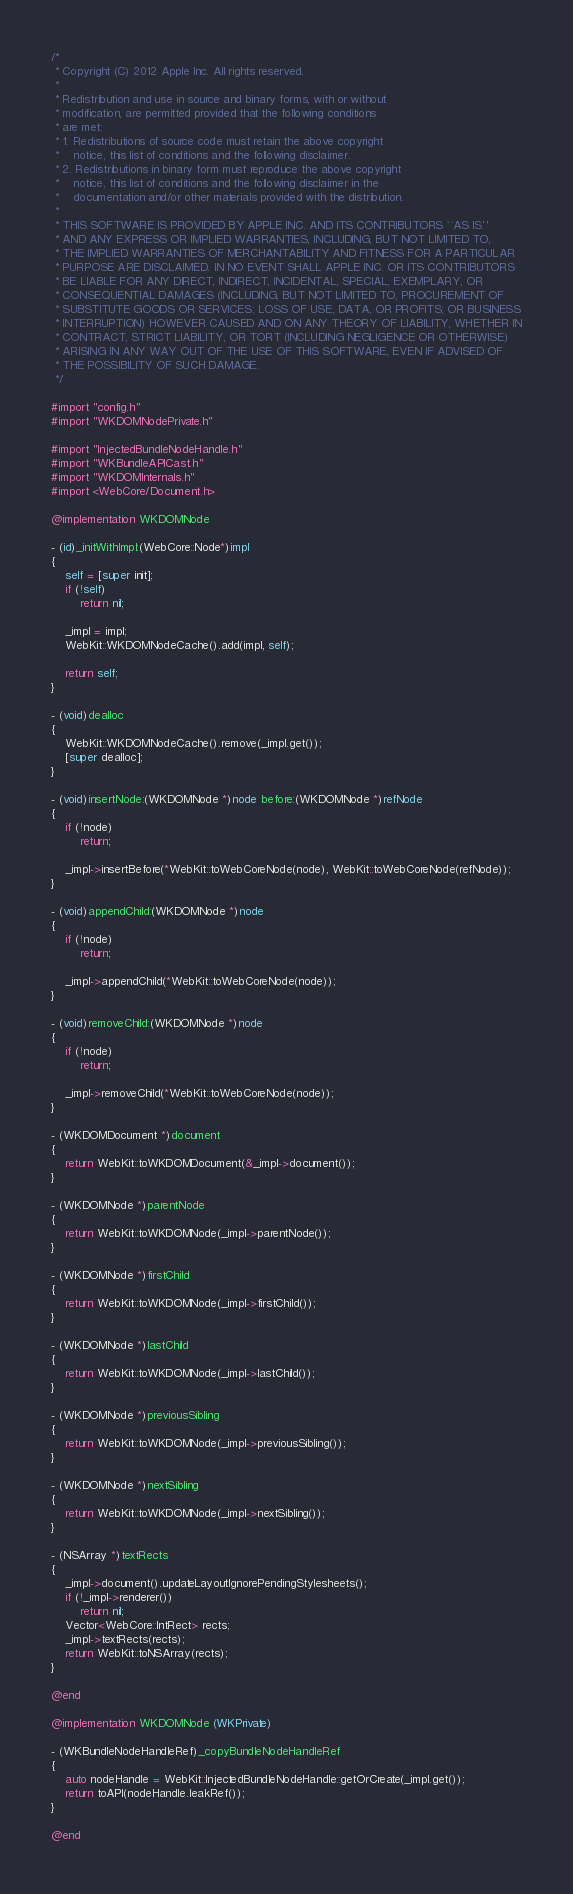<code> <loc_0><loc_0><loc_500><loc_500><_ObjectiveC_>/*
 * Copyright (C) 2012 Apple Inc. All rights reserved.
 *
 * Redistribution and use in source and binary forms, with or without
 * modification, are permitted provided that the following conditions
 * are met:
 * 1. Redistributions of source code must retain the above copyright
 *    notice, this list of conditions and the following disclaimer.
 * 2. Redistributions in binary form must reproduce the above copyright
 *    notice, this list of conditions and the following disclaimer in the
 *    documentation and/or other materials provided with the distribution.
 *
 * THIS SOFTWARE IS PROVIDED BY APPLE INC. AND ITS CONTRIBUTORS ``AS IS''
 * AND ANY EXPRESS OR IMPLIED WARRANTIES, INCLUDING, BUT NOT LIMITED TO,
 * THE IMPLIED WARRANTIES OF MERCHANTABILITY AND FITNESS FOR A PARTICULAR
 * PURPOSE ARE DISCLAIMED. IN NO EVENT SHALL APPLE INC. OR ITS CONTRIBUTORS
 * BE LIABLE FOR ANY DIRECT, INDIRECT, INCIDENTAL, SPECIAL, EXEMPLARY, OR
 * CONSEQUENTIAL DAMAGES (INCLUDING, BUT NOT LIMITED TO, PROCUREMENT OF
 * SUBSTITUTE GOODS OR SERVICES; LOSS OF USE, DATA, OR PROFITS; OR BUSINESS
 * INTERRUPTION) HOWEVER CAUSED AND ON ANY THEORY OF LIABILITY, WHETHER IN
 * CONTRACT, STRICT LIABILITY, OR TORT (INCLUDING NEGLIGENCE OR OTHERWISE)
 * ARISING IN ANY WAY OUT OF THE USE OF THIS SOFTWARE, EVEN IF ADVISED OF
 * THE POSSIBILITY OF SUCH DAMAGE.
 */

#import "config.h"
#import "WKDOMNodePrivate.h"

#import "InjectedBundleNodeHandle.h"
#import "WKBundleAPICast.h"
#import "WKDOMInternals.h"
#import <WebCore/Document.h>

@implementation WKDOMNode

- (id)_initWithImpl:(WebCore::Node*)impl
{
    self = [super init];
    if (!self)
        return nil;

    _impl = impl;
    WebKit::WKDOMNodeCache().add(impl, self);

    return self;
}

- (void)dealloc
{
    WebKit::WKDOMNodeCache().remove(_impl.get());
    [super dealloc];
}

- (void)insertNode:(WKDOMNode *)node before:(WKDOMNode *)refNode
{
    if (!node)
        return;

    _impl->insertBefore(*WebKit::toWebCoreNode(node), WebKit::toWebCoreNode(refNode));
}

- (void)appendChild:(WKDOMNode *)node
{
    if (!node)
        return;

    _impl->appendChild(*WebKit::toWebCoreNode(node));
}

- (void)removeChild:(WKDOMNode *)node
{
    if (!node)
        return;

    _impl->removeChild(*WebKit::toWebCoreNode(node));
}

- (WKDOMDocument *)document
{
    return WebKit::toWKDOMDocument(&_impl->document());
}

- (WKDOMNode *)parentNode
{
    return WebKit::toWKDOMNode(_impl->parentNode());
}

- (WKDOMNode *)firstChild
{
    return WebKit::toWKDOMNode(_impl->firstChild());
}

- (WKDOMNode *)lastChild
{
    return WebKit::toWKDOMNode(_impl->lastChild());
}

- (WKDOMNode *)previousSibling
{
    return WebKit::toWKDOMNode(_impl->previousSibling());
}

- (WKDOMNode *)nextSibling
{
    return WebKit::toWKDOMNode(_impl->nextSibling());
}

- (NSArray *)textRects
{
    _impl->document().updateLayoutIgnorePendingStylesheets();
    if (!_impl->renderer())
        return nil;
    Vector<WebCore::IntRect> rects;
    _impl->textRects(rects);
    return WebKit::toNSArray(rects);
}

@end

@implementation WKDOMNode (WKPrivate)

- (WKBundleNodeHandleRef)_copyBundleNodeHandleRef
{
    auto nodeHandle = WebKit::InjectedBundleNodeHandle::getOrCreate(_impl.get());
    return toAPI(nodeHandle.leakRef());
}

@end
</code> 